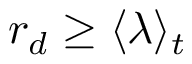<formula> <loc_0><loc_0><loc_500><loc_500>r _ { d } \geq \langle \lambda \rangle _ { t }</formula> 